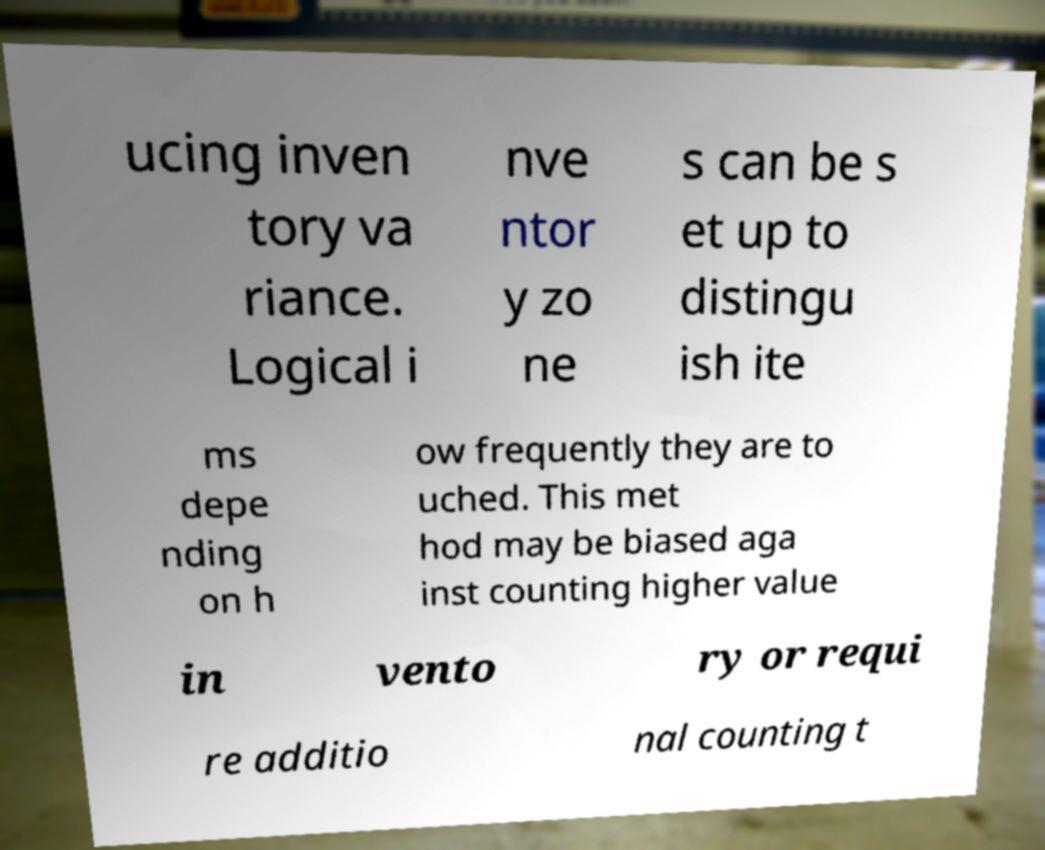There's text embedded in this image that I need extracted. Can you transcribe it verbatim? ucing inven tory va riance. Logical i nve ntor y zo ne s can be s et up to distingu ish ite ms depe nding on h ow frequently they are to uched. This met hod may be biased aga inst counting higher value in vento ry or requi re additio nal counting t 